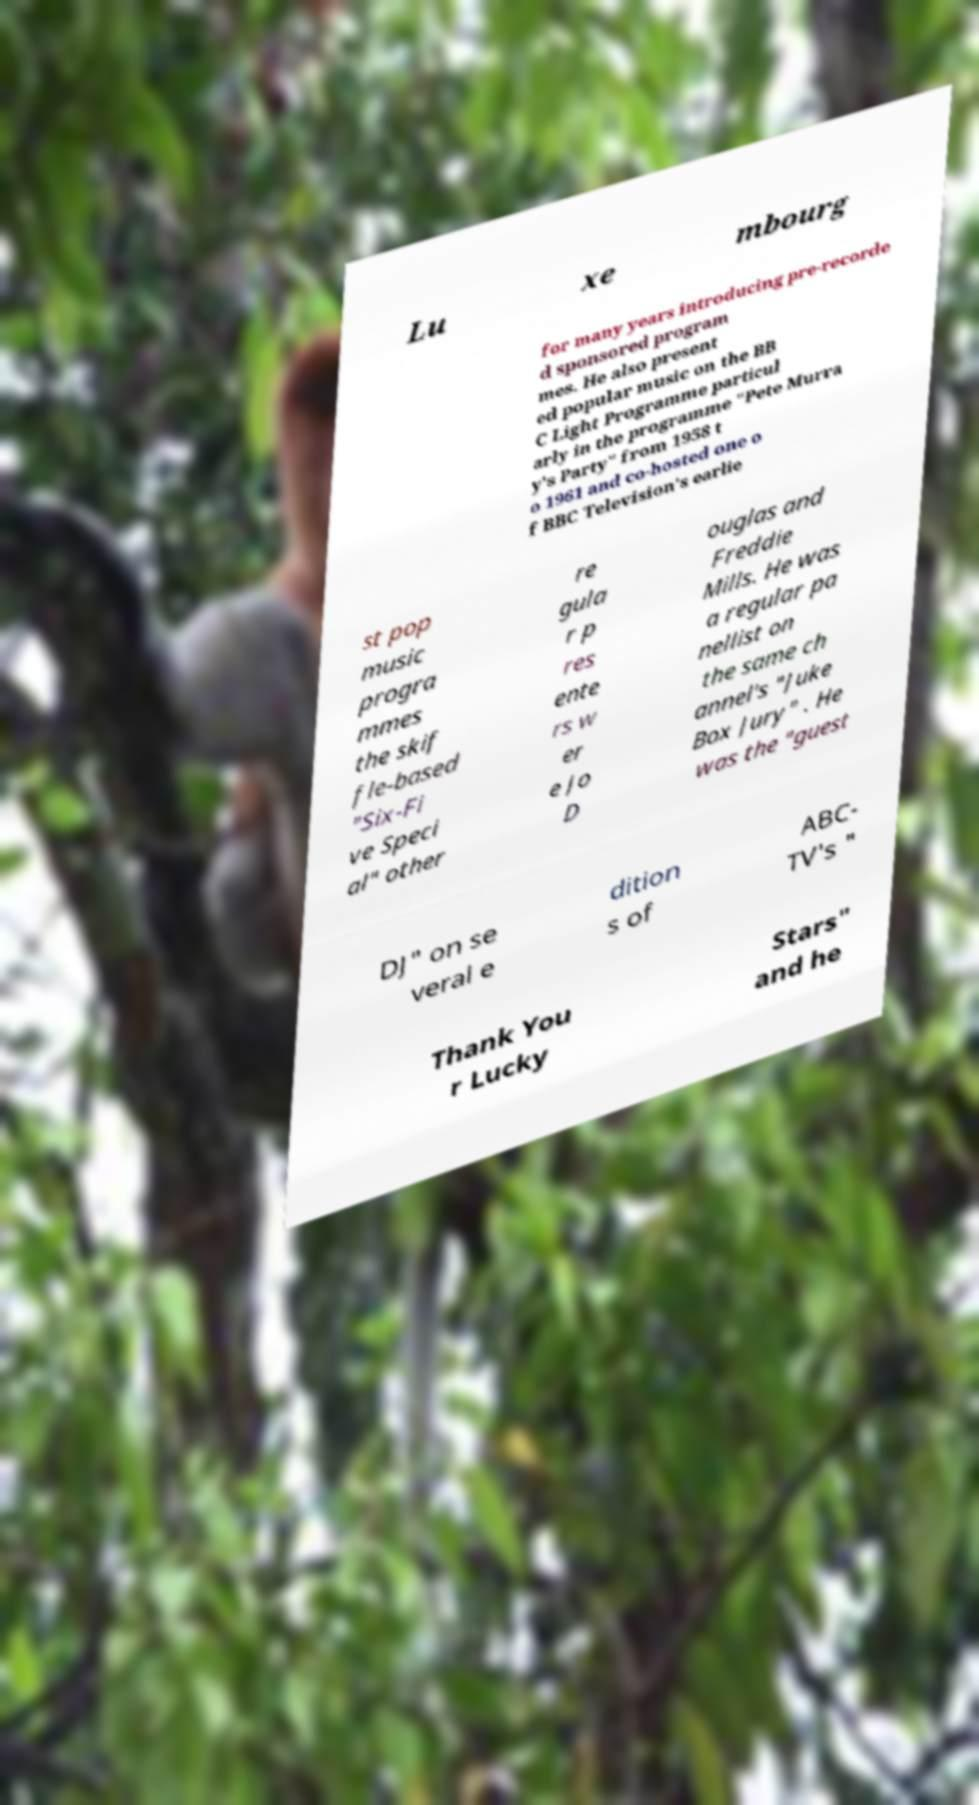Could you extract and type out the text from this image? Lu xe mbourg for many years introducing pre-recorde d sponsored program mes. He also present ed popular music on the BB C Light Programme particul arly in the programme "Pete Murra y's Party" from 1958 t o 1961 and co-hosted one o f BBC Television's earlie st pop music progra mmes the skif fle-based "Six-Fi ve Speci al" other re gula r p res ente rs w er e Jo D ouglas and Freddie Mills. He was a regular pa nellist on the same ch annel's "Juke Box Jury" . He was the "guest DJ" on se veral e dition s of ABC- TV's " Thank You r Lucky Stars" and he 